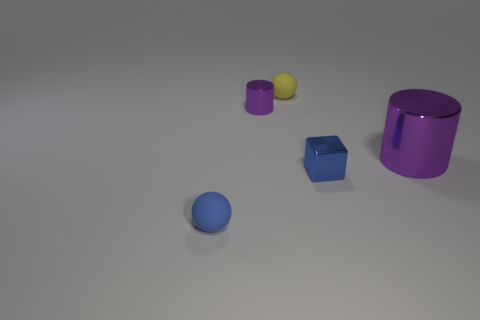There is a small yellow rubber thing behind the purple cylinder behind the large purple metal cylinder; what number of metallic cylinders are to the left of it?
Give a very brief answer. 1. There is a tiny purple thing that is the same shape as the large metallic object; what is it made of?
Give a very brief answer. Metal. What material is the thing that is both right of the yellow ball and to the left of the large purple shiny cylinder?
Your response must be concise. Metal. Are there fewer small shiny cylinders that are in front of the big purple cylinder than cylinders that are on the right side of the tiny yellow ball?
Give a very brief answer. Yes. How many other things are there of the same size as the blue block?
Ensure brevity in your answer.  3. There is a shiny object that is to the left of the small matte ball that is behind the small blue thing to the left of the blue metallic block; what is its shape?
Offer a very short reply. Cylinder. What number of cyan objects are spheres or blocks?
Keep it short and to the point. 0. There is a tiny sphere behind the small cylinder; how many tiny balls are behind it?
Ensure brevity in your answer.  0. Is there any other thing that has the same color as the small metallic cylinder?
Provide a short and direct response. Yes. There is a purple object that is the same material as the big purple cylinder; what shape is it?
Provide a succinct answer. Cylinder. 